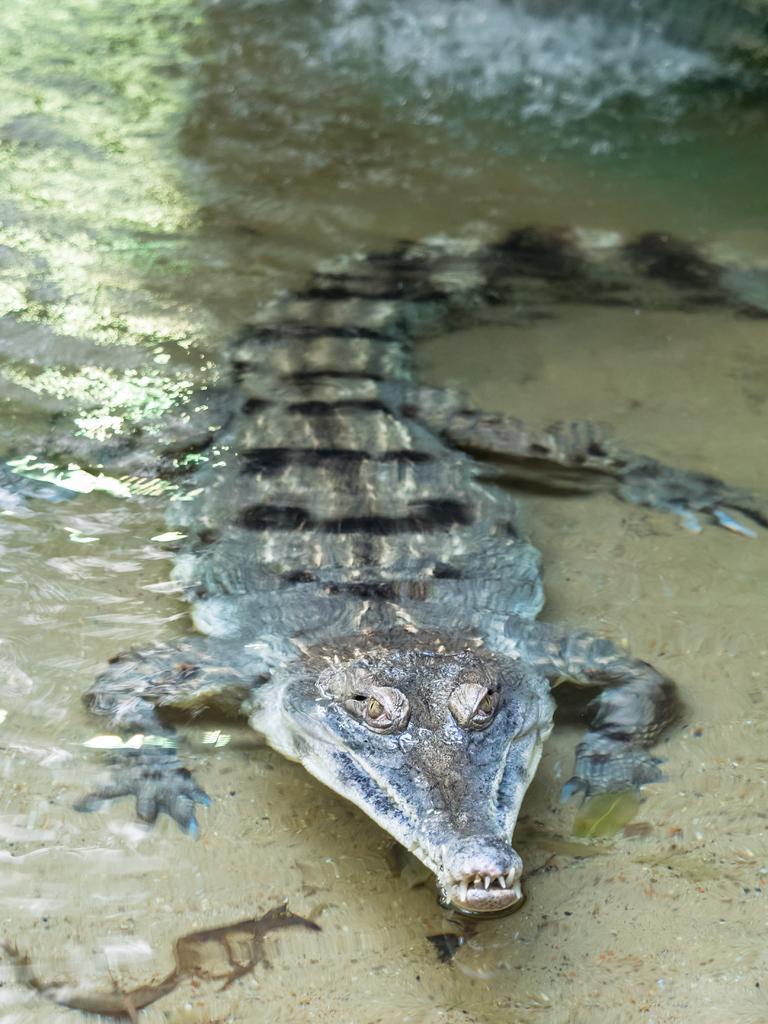Can you describe this image briefly? In this picture we can see a brown color crocodile in the water seen in the middle of the image. 